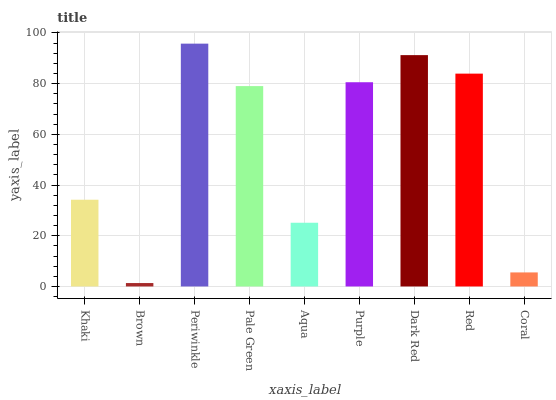Is Brown the minimum?
Answer yes or no. Yes. Is Periwinkle the maximum?
Answer yes or no. Yes. Is Periwinkle the minimum?
Answer yes or no. No. Is Brown the maximum?
Answer yes or no. No. Is Periwinkle greater than Brown?
Answer yes or no. Yes. Is Brown less than Periwinkle?
Answer yes or no. Yes. Is Brown greater than Periwinkle?
Answer yes or no. No. Is Periwinkle less than Brown?
Answer yes or no. No. Is Pale Green the high median?
Answer yes or no. Yes. Is Pale Green the low median?
Answer yes or no. Yes. Is Periwinkle the high median?
Answer yes or no. No. Is Periwinkle the low median?
Answer yes or no. No. 